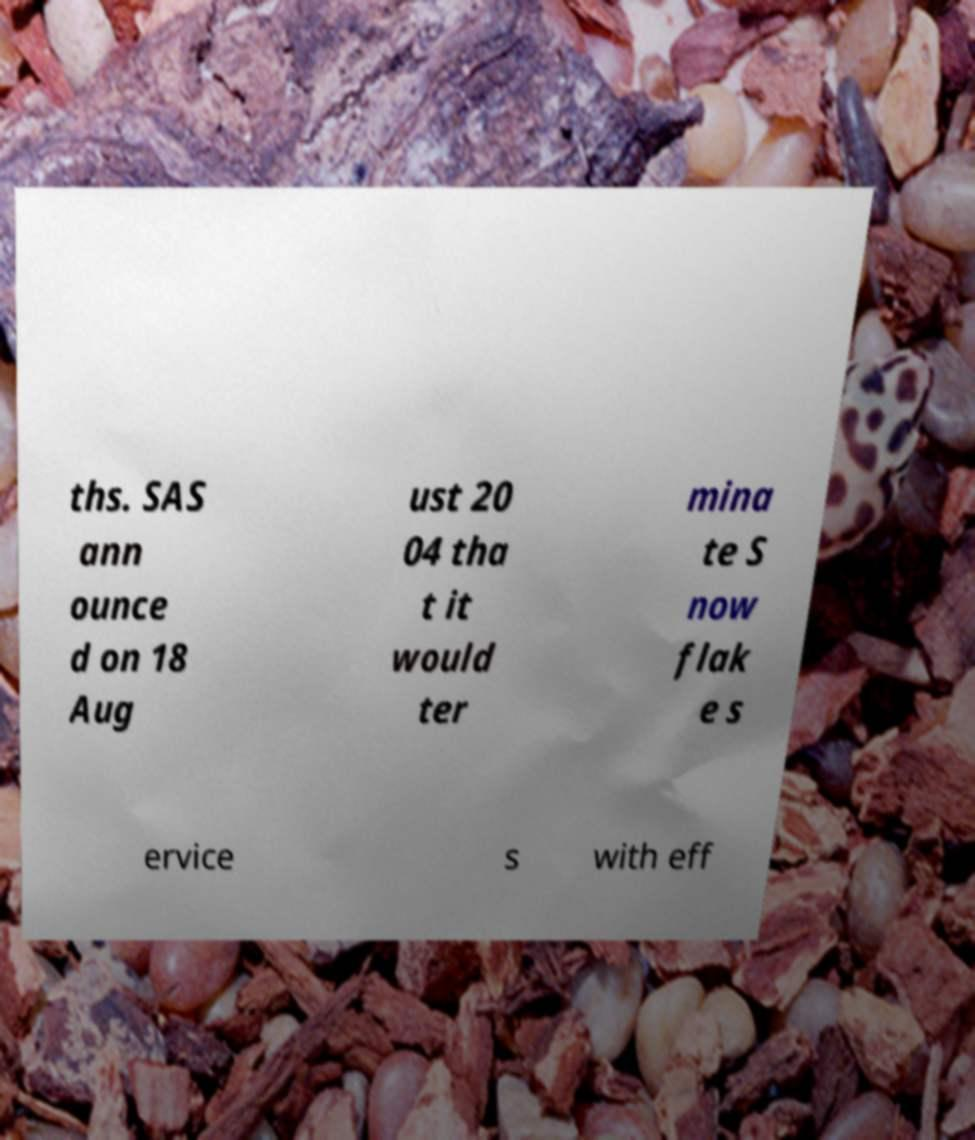Can you read and provide the text displayed in the image?This photo seems to have some interesting text. Can you extract and type it out for me? ths. SAS ann ounce d on 18 Aug ust 20 04 tha t it would ter mina te S now flak e s ervice s with eff 